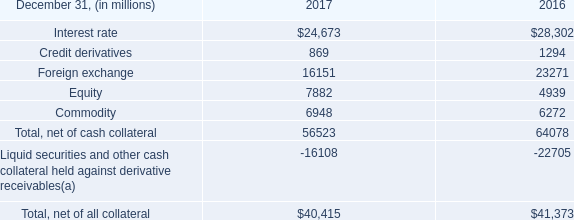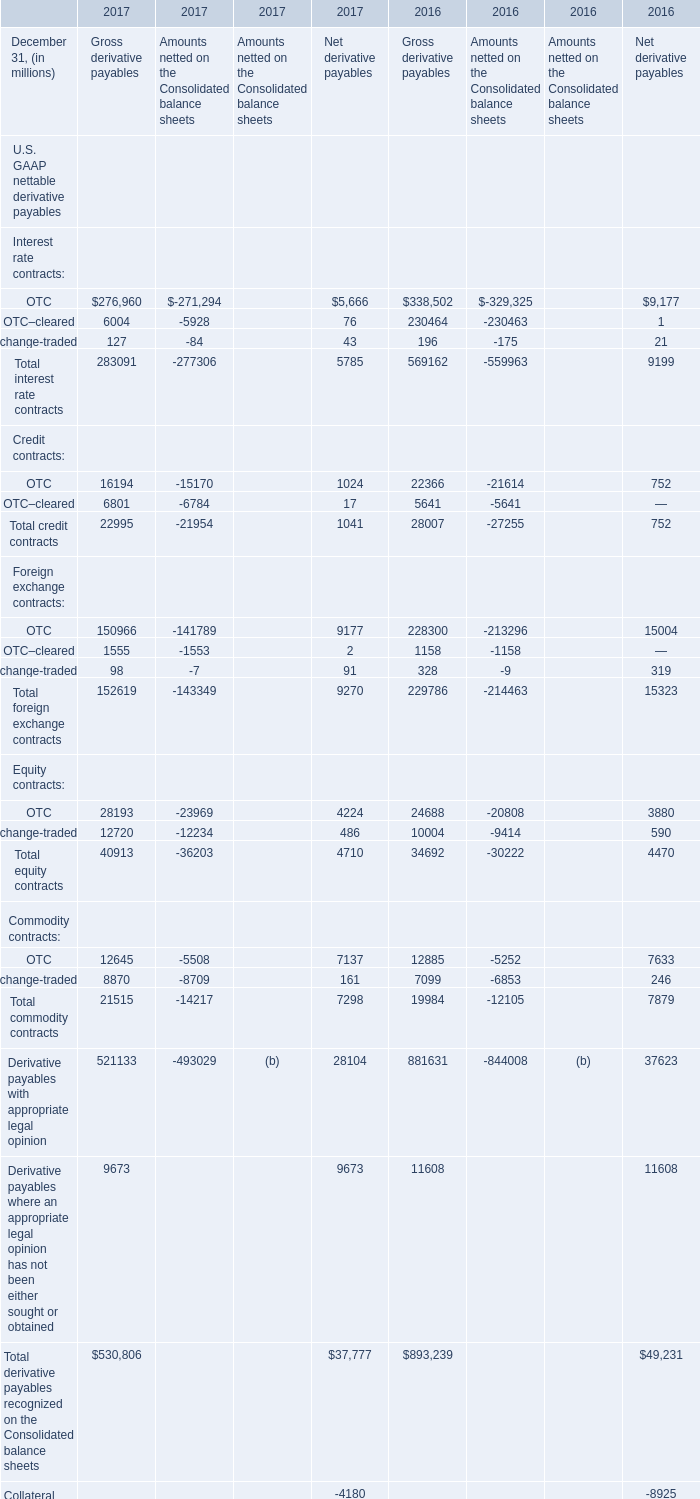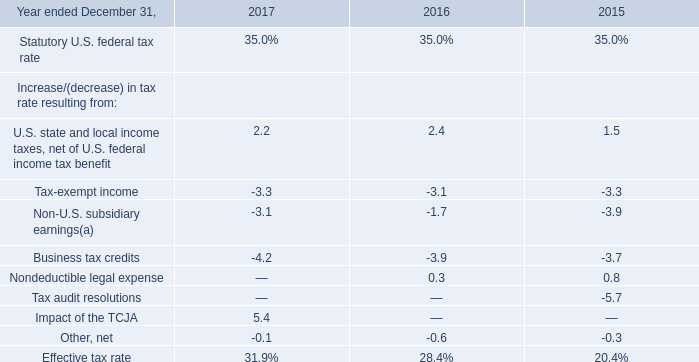what was the ratio of the derivative receivables reported on the consolidated balance sheets for 2016 to 2017 
Computations: (64.1 / 56.5)
Answer: 1.13451. 